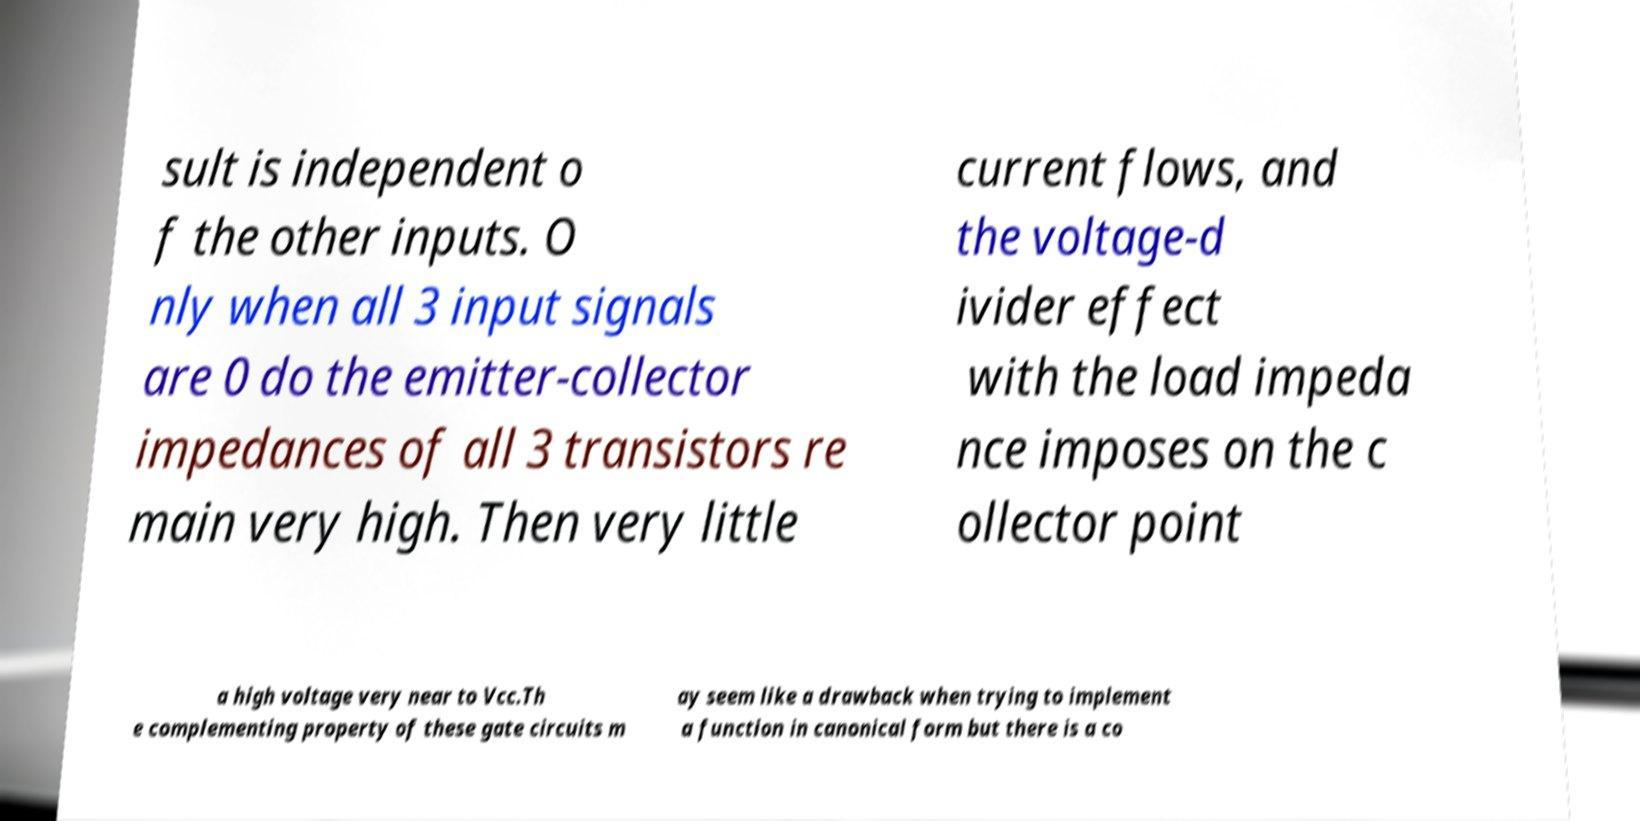Can you accurately transcribe the text from the provided image for me? sult is independent o f the other inputs. O nly when all 3 input signals are 0 do the emitter-collector impedances of all 3 transistors re main very high. Then very little current flows, and the voltage-d ivider effect with the load impeda nce imposes on the c ollector point a high voltage very near to Vcc.Th e complementing property of these gate circuits m ay seem like a drawback when trying to implement a function in canonical form but there is a co 